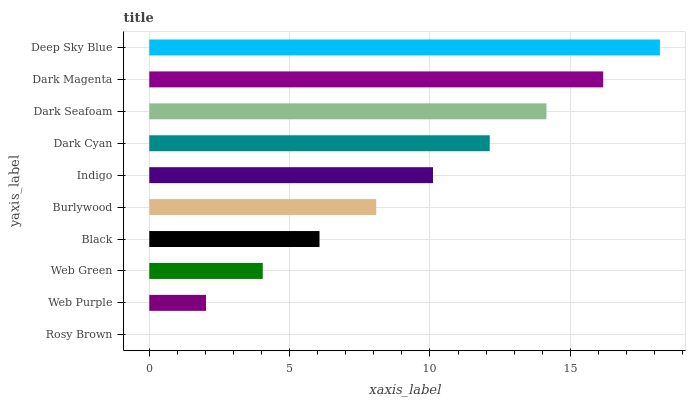Is Rosy Brown the minimum?
Answer yes or no. Yes. Is Deep Sky Blue the maximum?
Answer yes or no. Yes. Is Web Purple the minimum?
Answer yes or no. No. Is Web Purple the maximum?
Answer yes or no. No. Is Web Purple greater than Rosy Brown?
Answer yes or no. Yes. Is Rosy Brown less than Web Purple?
Answer yes or no. Yes. Is Rosy Brown greater than Web Purple?
Answer yes or no. No. Is Web Purple less than Rosy Brown?
Answer yes or no. No. Is Indigo the high median?
Answer yes or no. Yes. Is Burlywood the low median?
Answer yes or no. Yes. Is Web Green the high median?
Answer yes or no. No. Is Rosy Brown the low median?
Answer yes or no. No. 